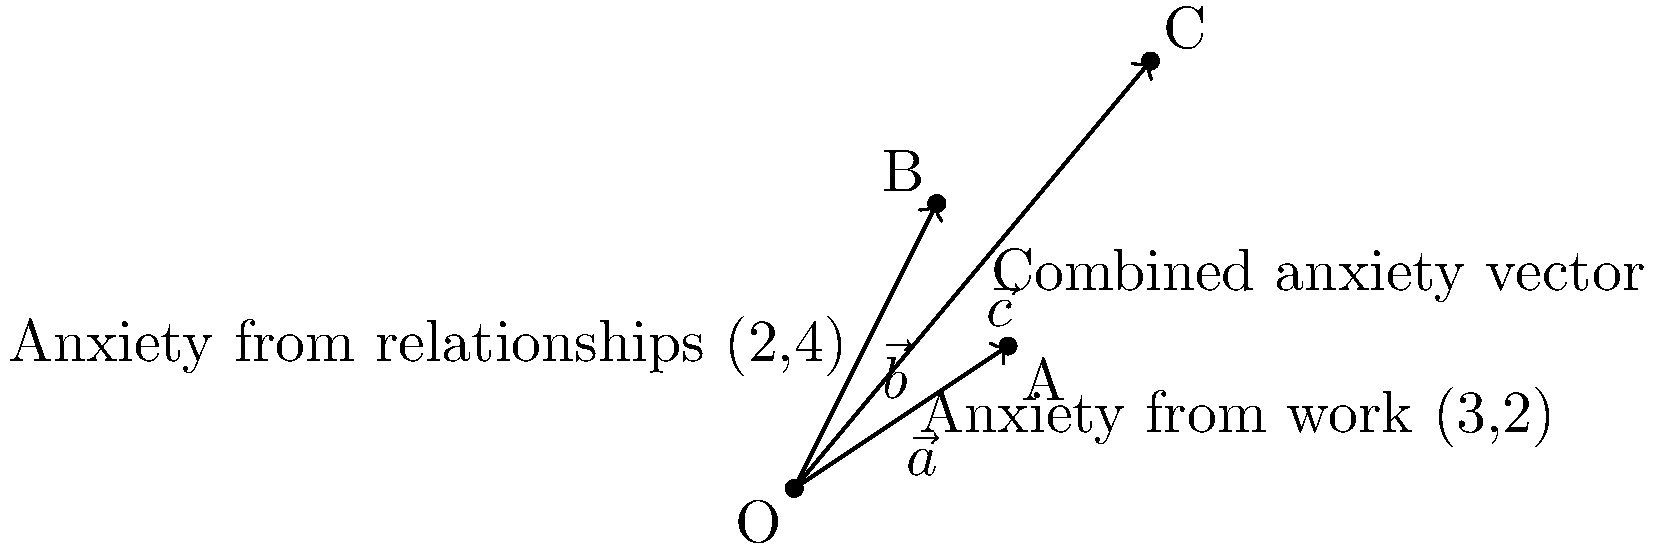In your research on anxiety triggers, you model different sources of anxiety as vectors. Vector $\vec{a} = (3,2)$ represents anxiety from work, and vector $\vec{b} = (2,4)$ represents anxiety from relationships. If these anxiety sources combine additively, what is the magnitude of the resulting anxiety vector $\vec{c}$? Round your answer to two decimal places. To solve this problem, we'll follow these steps:

1) First, we need to find the combined anxiety vector $\vec{c}$. Since the anxiety sources combine additively, we can use vector addition:

   $\vec{c} = \vec{a} + \vec{b} = (3,2) + (2,4) = (5,6)$

2) Now that we have the combined vector $\vec{c} = (5,6)$, we need to calculate its magnitude. The magnitude of a vector $(x,y)$ is given by the formula:

   $\|\vec{v}\| = \sqrt{x^2 + y^2}$

3) Substituting our values:

   $\|\vec{c}\| = \sqrt{5^2 + 6^2}$

4) Simplify:

   $\|\vec{c}\| = \sqrt{25 + 36} = \sqrt{61}$

5) Calculate and round to two decimal places:

   $\|\vec{c}\| \approx 7.81$

Therefore, the magnitude of the resulting anxiety vector is approximately 7.81.
Answer: 7.81 